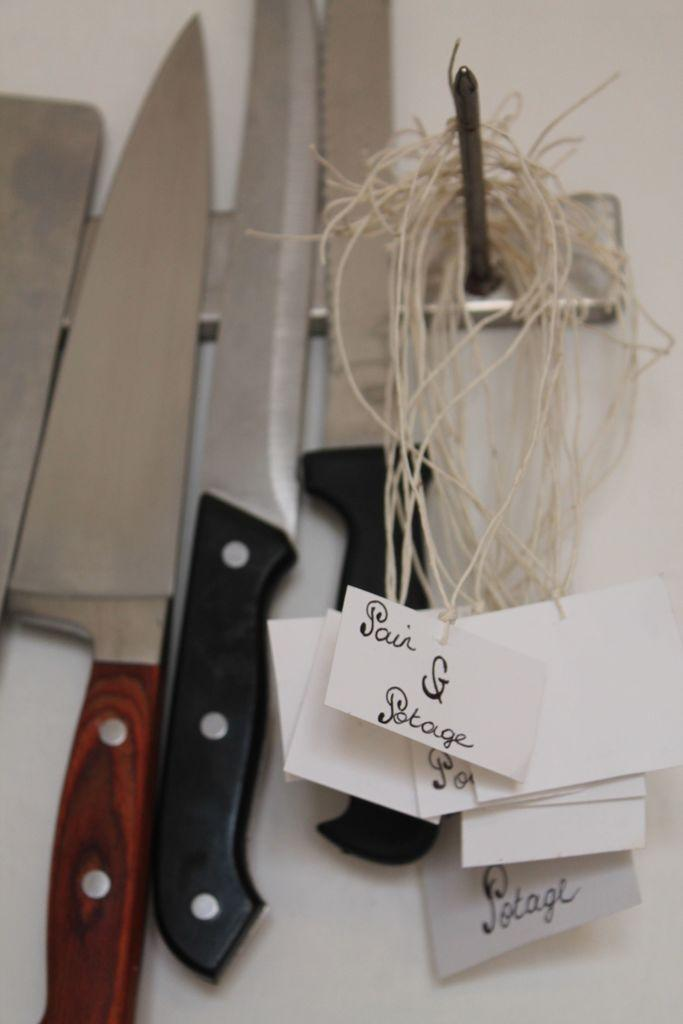What is the color of the surface in the image? The surface in the image is white. What objects are on the surface? There are knives on a stand in the image. What is attached to the nail in the image? There are threads with papers on the nail. What can be seen on the papers? Something is written on the papers. Reasoning: Let's think step by step by following the facts step by step to produce the conversation. We start by identifying the color of the surface, which is white. Then, we describe the objects on the surface, which are knives on a stand. Next, we focus on the nail and its attachments, which are threads with papers. Finally, we mention the content of the papers, which is something written. Absurd Question/Answer: What type of juice is being poured from the curve in the image? There is no juice or curve present in the image. 